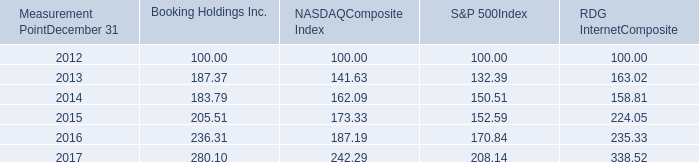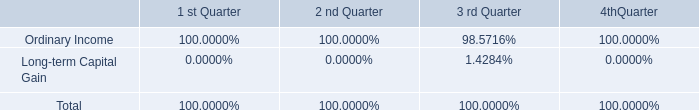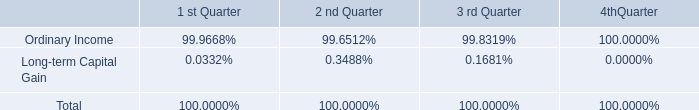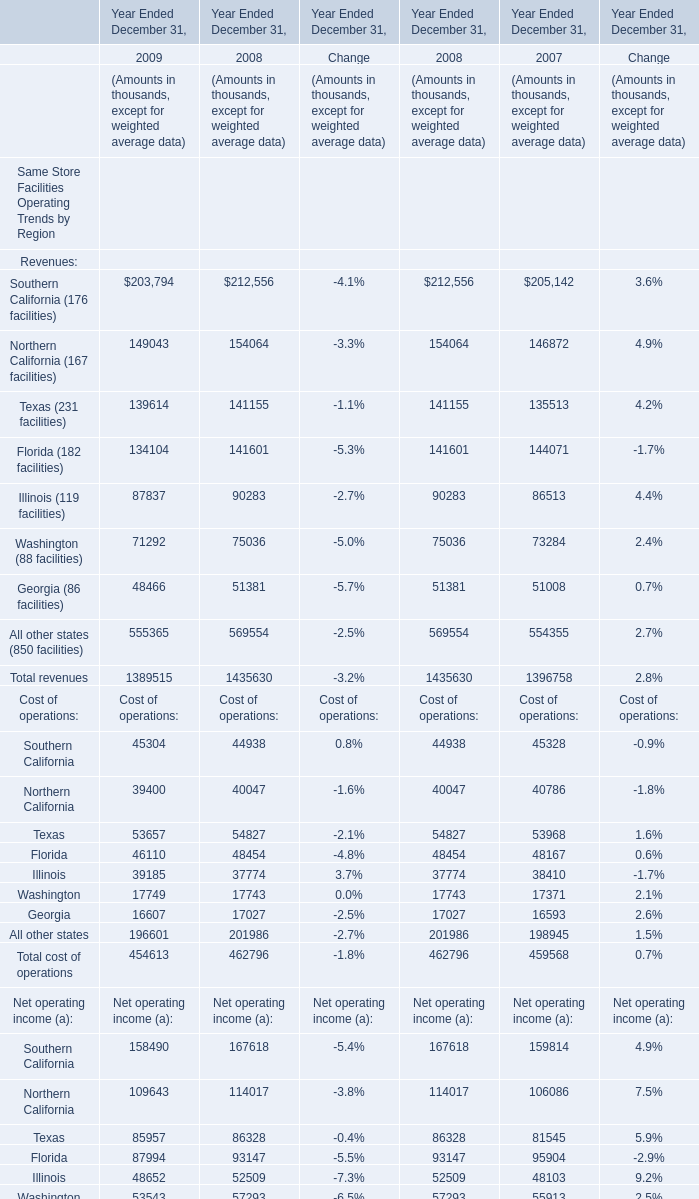How many element exceed the average of Southern California in 2008 and 2009 ? 
Answer: 12. 